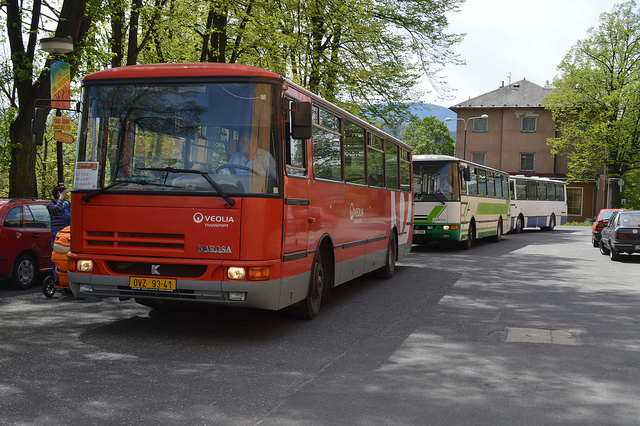Please identify all text content in this image. VEOUA 93-41 K 0YZ 